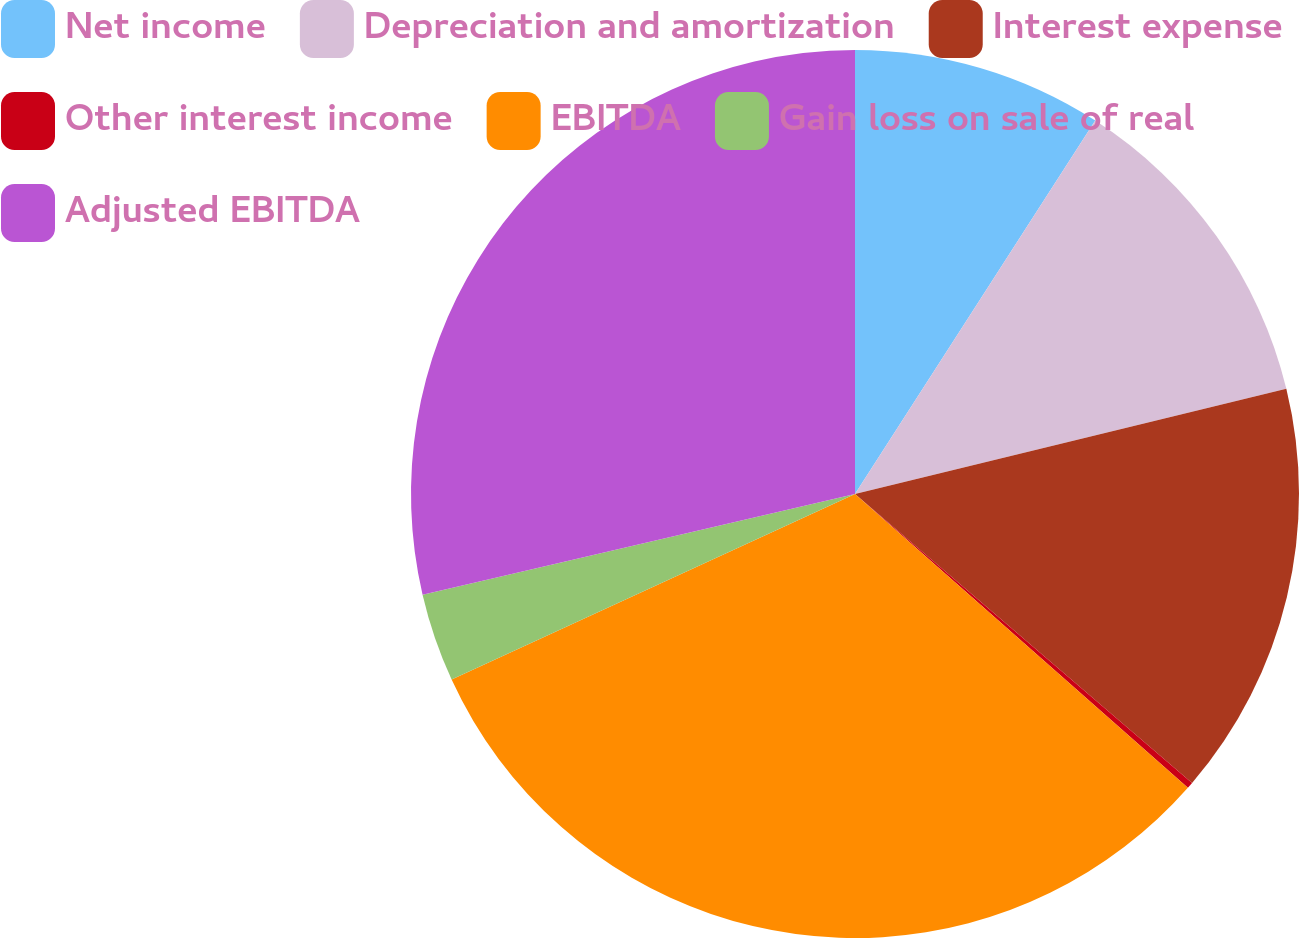Convert chart to OTSL. <chart><loc_0><loc_0><loc_500><loc_500><pie_chart><fcel>Net income<fcel>Depreciation and amortization<fcel>Interest expense<fcel>Other interest income<fcel>EBITDA<fcel>Gain loss on sale of real<fcel>Adjusted EBITDA<nl><fcel>9.1%<fcel>12.09%<fcel>15.09%<fcel>0.23%<fcel>31.63%<fcel>3.22%<fcel>28.64%<nl></chart> 